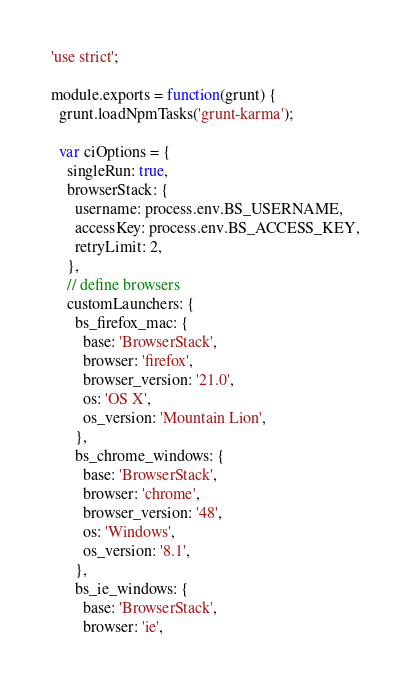Convert code to text. <code><loc_0><loc_0><loc_500><loc_500><_JavaScript_>'use strict';

module.exports = function(grunt) {
  grunt.loadNpmTasks('grunt-karma');

  var ciOptions = {
    singleRun: true,
    browserStack: {
      username: process.env.BS_USERNAME,
      accessKey: process.env.BS_ACCESS_KEY,
      retryLimit: 2,
    },
    // define browsers
    customLaunchers: {
      bs_firefox_mac: {
        base: 'BrowserStack',
        browser: 'firefox',
        browser_version: '21.0',
        os: 'OS X',
        os_version: 'Mountain Lion',
      },
      bs_chrome_windows: {
        base: 'BrowserStack',
        browser: 'chrome',
        browser_version: '48',
        os: 'Windows',
        os_version: '8.1',
      },
      bs_ie_windows: {
        base: 'BrowserStack',
        browser: 'ie',</code> 